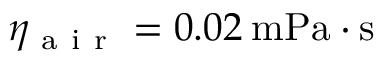<formula> <loc_0><loc_0><loc_500><loc_500>\eta _ { a i r } = 0 . 0 2 \, m P a \cdot s</formula> 